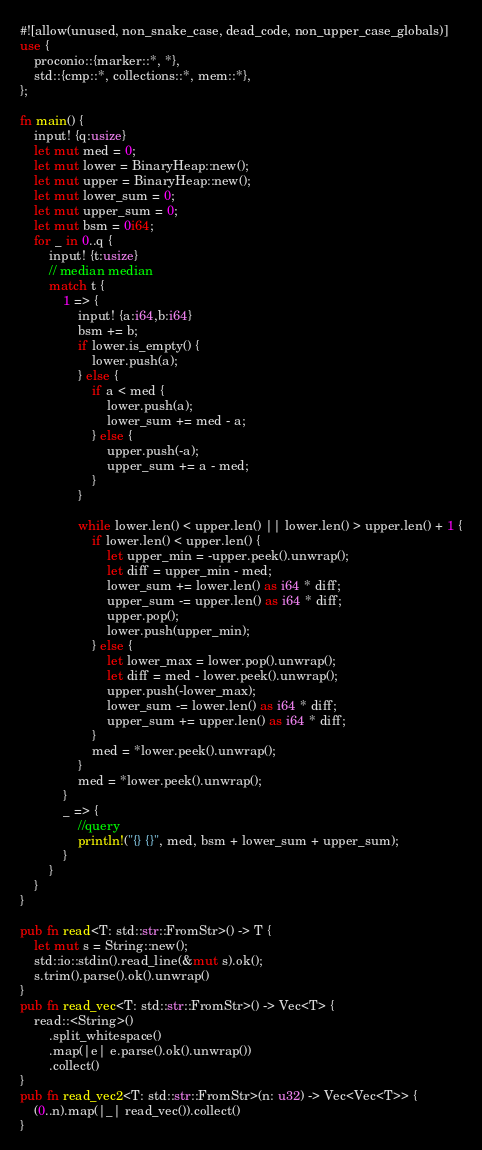<code> <loc_0><loc_0><loc_500><loc_500><_Rust_>#![allow(unused, non_snake_case, dead_code, non_upper_case_globals)]
use {
    proconio::{marker::*, *},
    std::{cmp::*, collections::*, mem::*},
};

fn main() {
    input! {q:usize}
    let mut med = 0;
    let mut lower = BinaryHeap::new();
    let mut upper = BinaryHeap::new();
    let mut lower_sum = 0;
    let mut upper_sum = 0;
    let mut bsm = 0i64;
    for _ in 0..q {
        input! {t:usize}
        // median median
        match t {
            1 => {
                input! {a:i64,b:i64}
                bsm += b;
                if lower.is_empty() {
                    lower.push(a);
                } else {
                    if a < med {
                        lower.push(a);
                        lower_sum += med - a;
                    } else {
                        upper.push(-a);
                        upper_sum += a - med;
                    }
                }

                while lower.len() < upper.len() || lower.len() > upper.len() + 1 {
                    if lower.len() < upper.len() {
                        let upper_min = -upper.peek().unwrap();
                        let diff = upper_min - med;
                        lower_sum += lower.len() as i64 * diff;
                        upper_sum -= upper.len() as i64 * diff;
                        upper.pop();
                        lower.push(upper_min);
                    } else {
                        let lower_max = lower.pop().unwrap();
                        let diff = med - lower.peek().unwrap();
                        upper.push(-lower_max);
                        lower_sum -= lower.len() as i64 * diff;
                        upper_sum += upper.len() as i64 * diff;
                    }
                    med = *lower.peek().unwrap();
                }
                med = *lower.peek().unwrap();
            }
            _ => {
                //query
                println!("{} {}", med, bsm + lower_sum + upper_sum);
            }
        }
    }
}

pub fn read<T: std::str::FromStr>() -> T {
    let mut s = String::new();
    std::io::stdin().read_line(&mut s).ok();
    s.trim().parse().ok().unwrap()
}
pub fn read_vec<T: std::str::FromStr>() -> Vec<T> {
    read::<String>()
        .split_whitespace()
        .map(|e| e.parse().ok().unwrap())
        .collect()
}
pub fn read_vec2<T: std::str::FromStr>(n: u32) -> Vec<Vec<T>> {
    (0..n).map(|_| read_vec()).collect()
}
</code> 